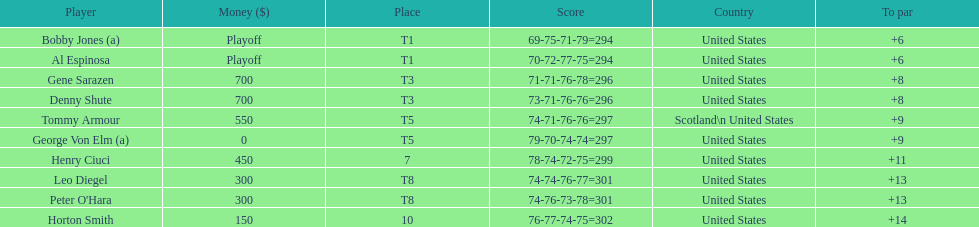How many players represented scotland? 1. 